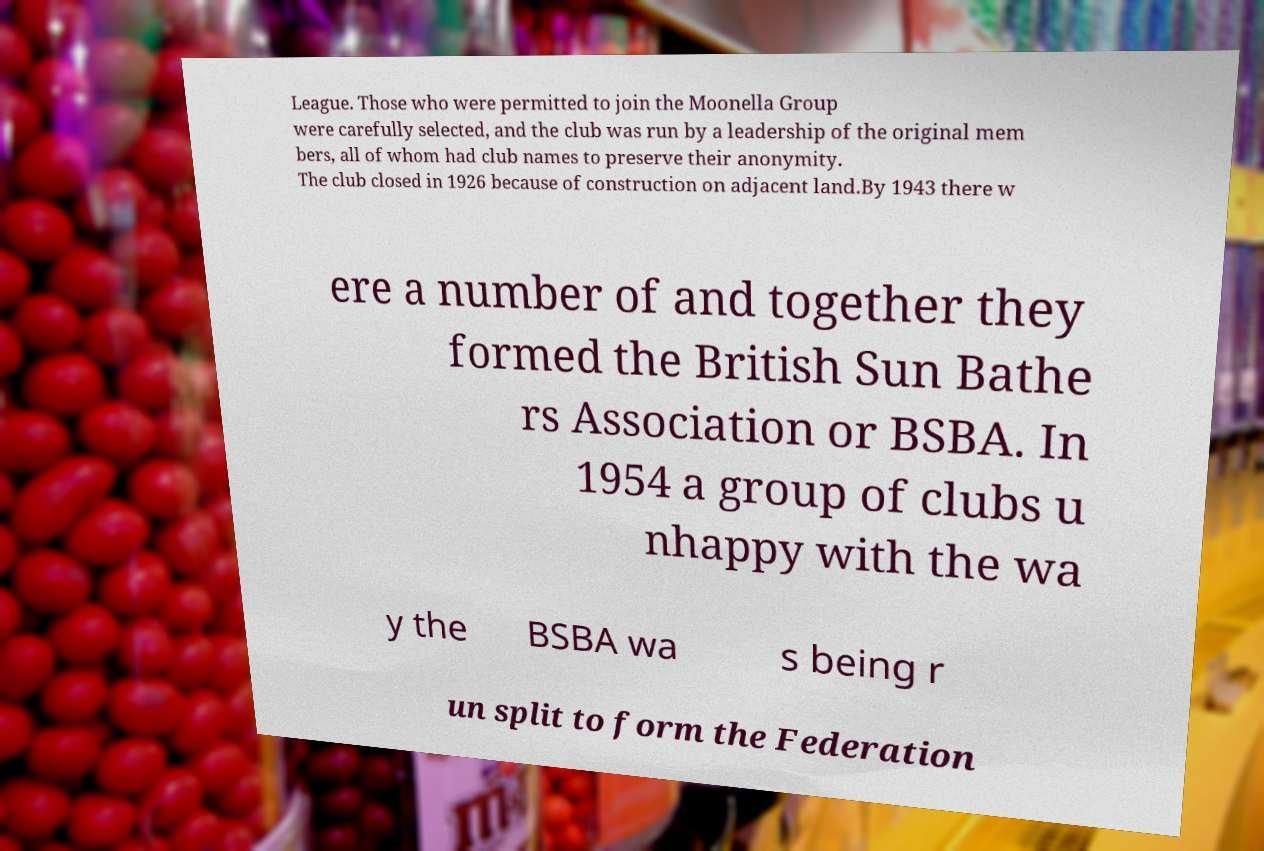For documentation purposes, I need the text within this image transcribed. Could you provide that? League. Those who were permitted to join the Moonella Group were carefully selected, and the club was run by a leadership of the original mem bers, all of whom had club names to preserve their anonymity. The club closed in 1926 because of construction on adjacent land.By 1943 there w ere a number of and together they formed the British Sun Bathe rs Association or BSBA. In 1954 a group of clubs u nhappy with the wa y the BSBA wa s being r un split to form the Federation 